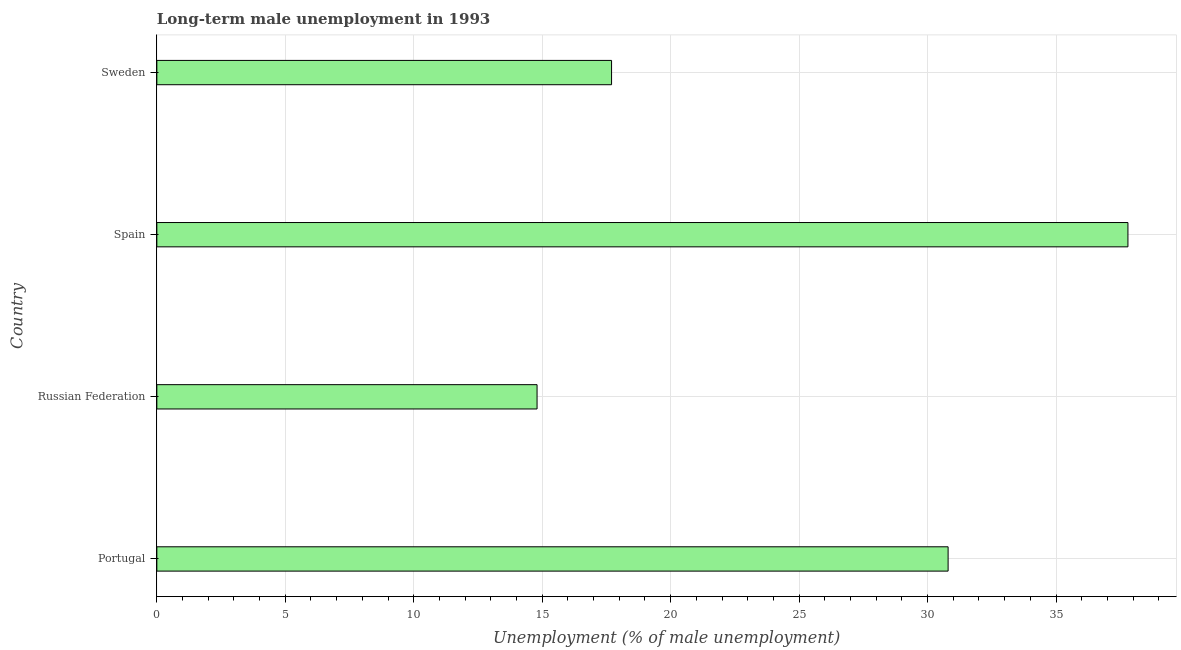Does the graph contain grids?
Your response must be concise. Yes. What is the title of the graph?
Ensure brevity in your answer.  Long-term male unemployment in 1993. What is the label or title of the X-axis?
Your answer should be compact. Unemployment (% of male unemployment). What is the label or title of the Y-axis?
Make the answer very short. Country. What is the long-term male unemployment in Portugal?
Provide a succinct answer. 30.8. Across all countries, what is the maximum long-term male unemployment?
Provide a succinct answer. 37.8. Across all countries, what is the minimum long-term male unemployment?
Offer a very short reply. 14.8. In which country was the long-term male unemployment maximum?
Offer a terse response. Spain. In which country was the long-term male unemployment minimum?
Your response must be concise. Russian Federation. What is the sum of the long-term male unemployment?
Keep it short and to the point. 101.1. What is the average long-term male unemployment per country?
Provide a succinct answer. 25.27. What is the median long-term male unemployment?
Your answer should be very brief. 24.25. In how many countries, is the long-term male unemployment greater than 2 %?
Your answer should be very brief. 4. What is the ratio of the long-term male unemployment in Portugal to that in Sweden?
Keep it short and to the point. 1.74. What is the difference between the highest and the second highest long-term male unemployment?
Give a very brief answer. 7. Is the sum of the long-term male unemployment in Portugal and Spain greater than the maximum long-term male unemployment across all countries?
Offer a terse response. Yes. How many bars are there?
Ensure brevity in your answer.  4. What is the difference between two consecutive major ticks on the X-axis?
Offer a terse response. 5. What is the Unemployment (% of male unemployment) of Portugal?
Make the answer very short. 30.8. What is the Unemployment (% of male unemployment) in Russian Federation?
Offer a terse response. 14.8. What is the Unemployment (% of male unemployment) in Spain?
Offer a very short reply. 37.8. What is the Unemployment (% of male unemployment) of Sweden?
Ensure brevity in your answer.  17.7. What is the difference between the Unemployment (% of male unemployment) in Portugal and Spain?
Make the answer very short. -7. What is the difference between the Unemployment (% of male unemployment) in Russian Federation and Sweden?
Make the answer very short. -2.9. What is the difference between the Unemployment (% of male unemployment) in Spain and Sweden?
Your answer should be very brief. 20.1. What is the ratio of the Unemployment (% of male unemployment) in Portugal to that in Russian Federation?
Provide a succinct answer. 2.08. What is the ratio of the Unemployment (% of male unemployment) in Portugal to that in Spain?
Your answer should be compact. 0.81. What is the ratio of the Unemployment (% of male unemployment) in Portugal to that in Sweden?
Give a very brief answer. 1.74. What is the ratio of the Unemployment (% of male unemployment) in Russian Federation to that in Spain?
Keep it short and to the point. 0.39. What is the ratio of the Unemployment (% of male unemployment) in Russian Federation to that in Sweden?
Provide a short and direct response. 0.84. What is the ratio of the Unemployment (% of male unemployment) in Spain to that in Sweden?
Keep it short and to the point. 2.14. 